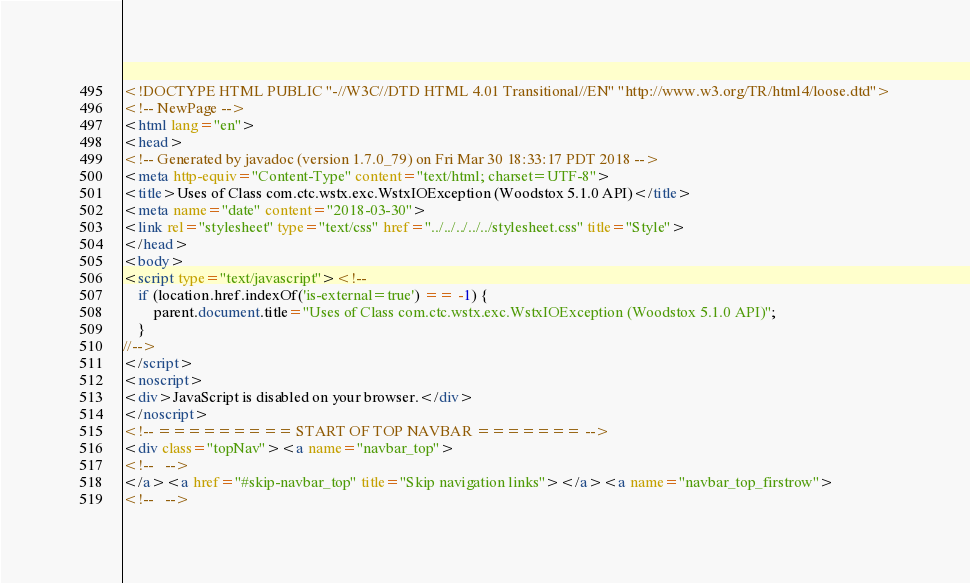Convert code to text. <code><loc_0><loc_0><loc_500><loc_500><_HTML_><!DOCTYPE HTML PUBLIC "-//W3C//DTD HTML 4.01 Transitional//EN" "http://www.w3.org/TR/html4/loose.dtd">
<!-- NewPage -->
<html lang="en">
<head>
<!-- Generated by javadoc (version 1.7.0_79) on Fri Mar 30 18:33:17 PDT 2018 -->
<meta http-equiv="Content-Type" content="text/html; charset=UTF-8">
<title>Uses of Class com.ctc.wstx.exc.WstxIOException (Woodstox 5.1.0 API)</title>
<meta name="date" content="2018-03-30">
<link rel="stylesheet" type="text/css" href="../../../../../stylesheet.css" title="Style">
</head>
<body>
<script type="text/javascript"><!--
    if (location.href.indexOf('is-external=true') == -1) {
        parent.document.title="Uses of Class com.ctc.wstx.exc.WstxIOException (Woodstox 5.1.0 API)";
    }
//-->
</script>
<noscript>
<div>JavaScript is disabled on your browser.</div>
</noscript>
<!-- ========= START OF TOP NAVBAR ======= -->
<div class="topNav"><a name="navbar_top">
<!--   -->
</a><a href="#skip-navbar_top" title="Skip navigation links"></a><a name="navbar_top_firstrow">
<!--   --></code> 